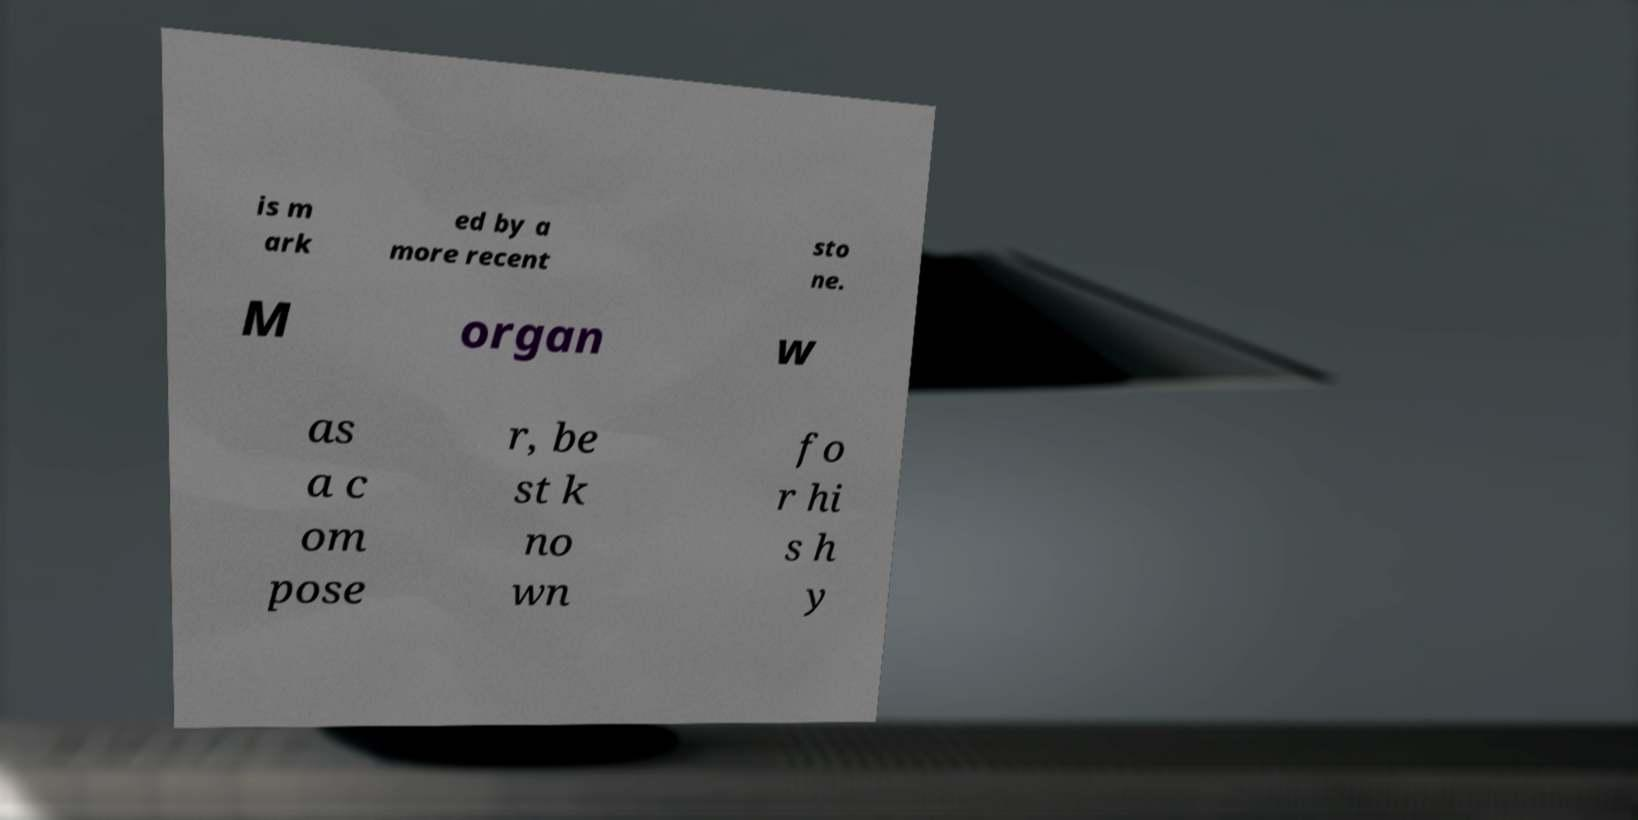What messages or text are displayed in this image? I need them in a readable, typed format. is m ark ed by a more recent sto ne. M organ w as a c om pose r, be st k no wn fo r hi s h y 